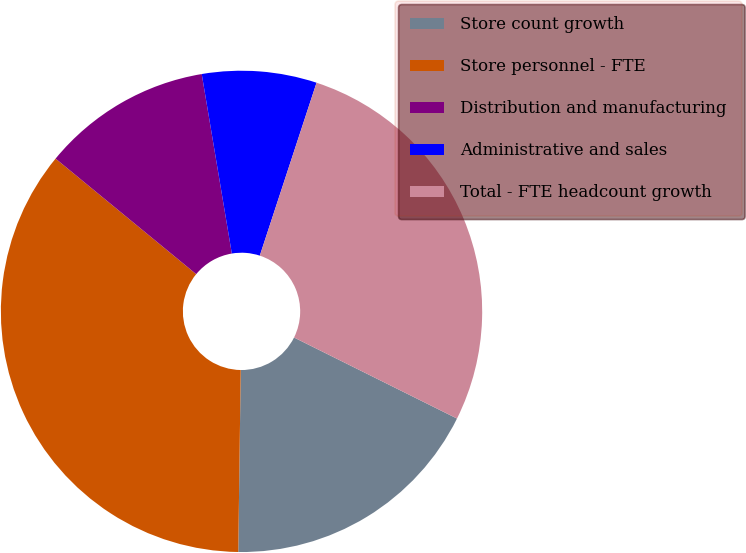Convert chart to OTSL. <chart><loc_0><loc_0><loc_500><loc_500><pie_chart><fcel>Store count growth<fcel>Store personnel - FTE<fcel>Distribution and manufacturing<fcel>Administrative and sales<fcel>Total - FTE headcount growth<nl><fcel>17.87%<fcel>35.73%<fcel>11.41%<fcel>7.69%<fcel>27.3%<nl></chart> 